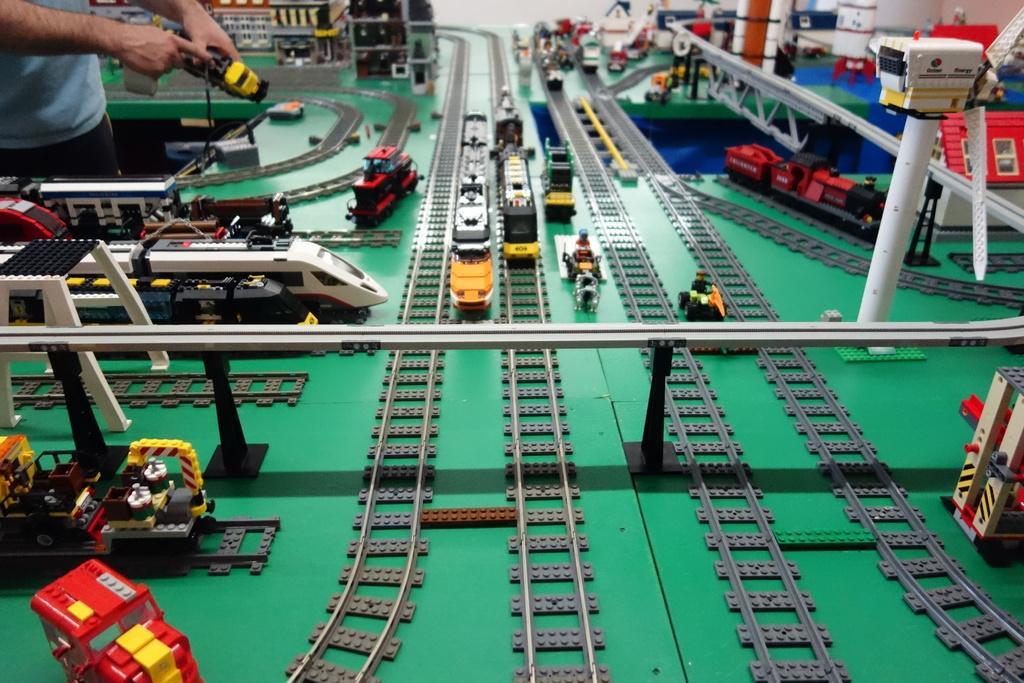Could you give a brief overview of what you see in this image? In this image I can see a few toy railway tracks, few toy trains on the tracks, a bridge, a windmill and few other toy vehicles. I can see a person is standing and holding a yellow and black colored toy in his hand. In the background I can see few toy houses, toy rockets and a toy house. 